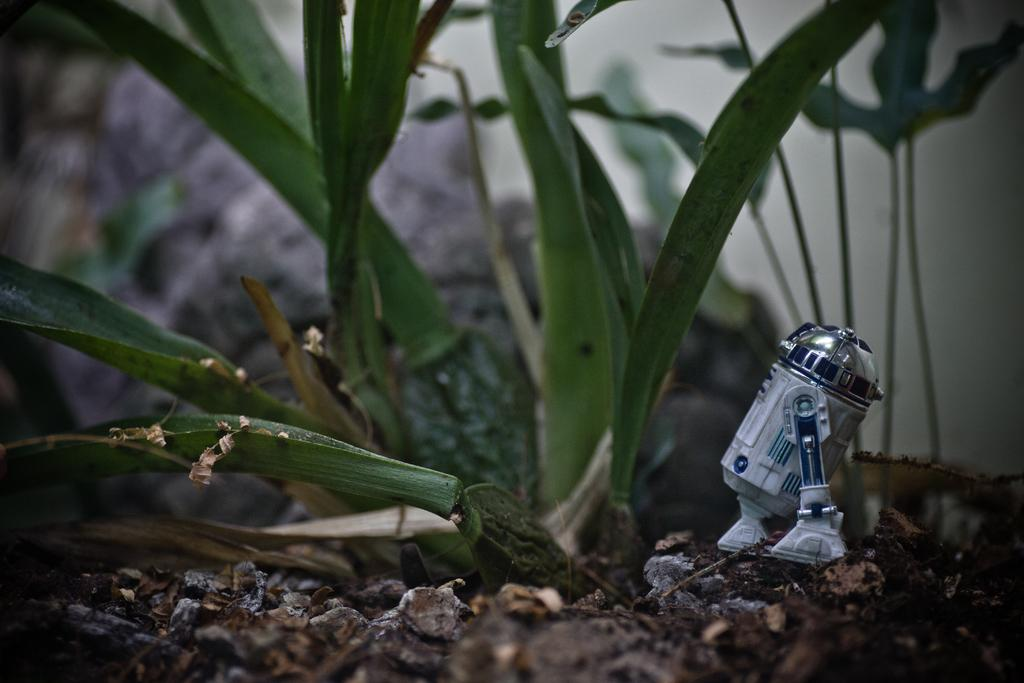What type of living organism can be seen in the image? There is a plant in the image. What can be found on the ground in the image? There are dried leaves on the ground in the image. What object in the image resembles a toy robot? There is an object in the image that resembles a toy robot. What type of jelly can be seen on the plant in the image? There is no jelly present on the plant in the image. 